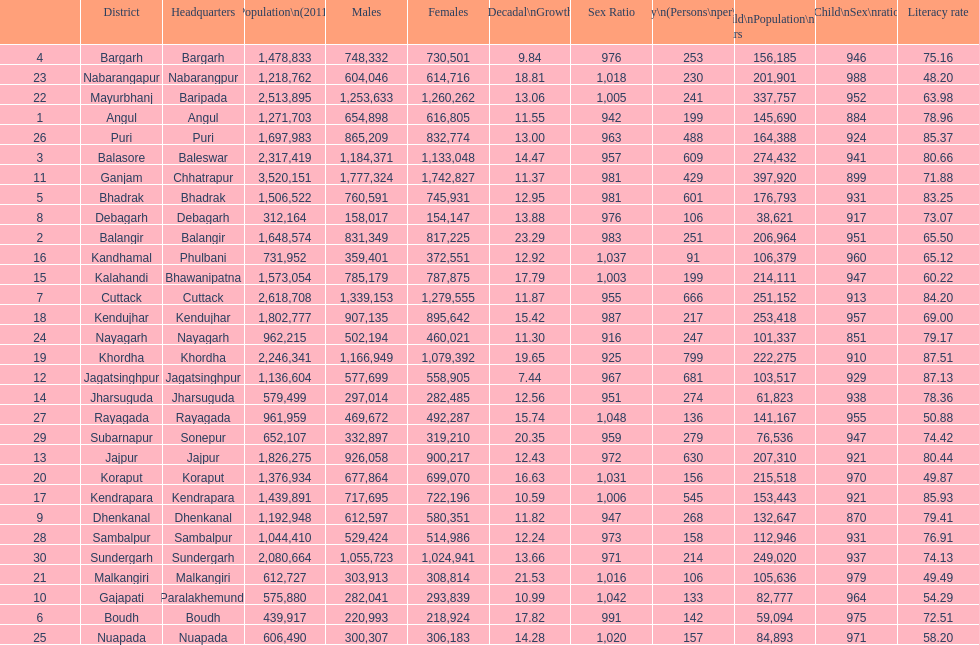In which district was there the maximum population per square kilometer? Khordha. 